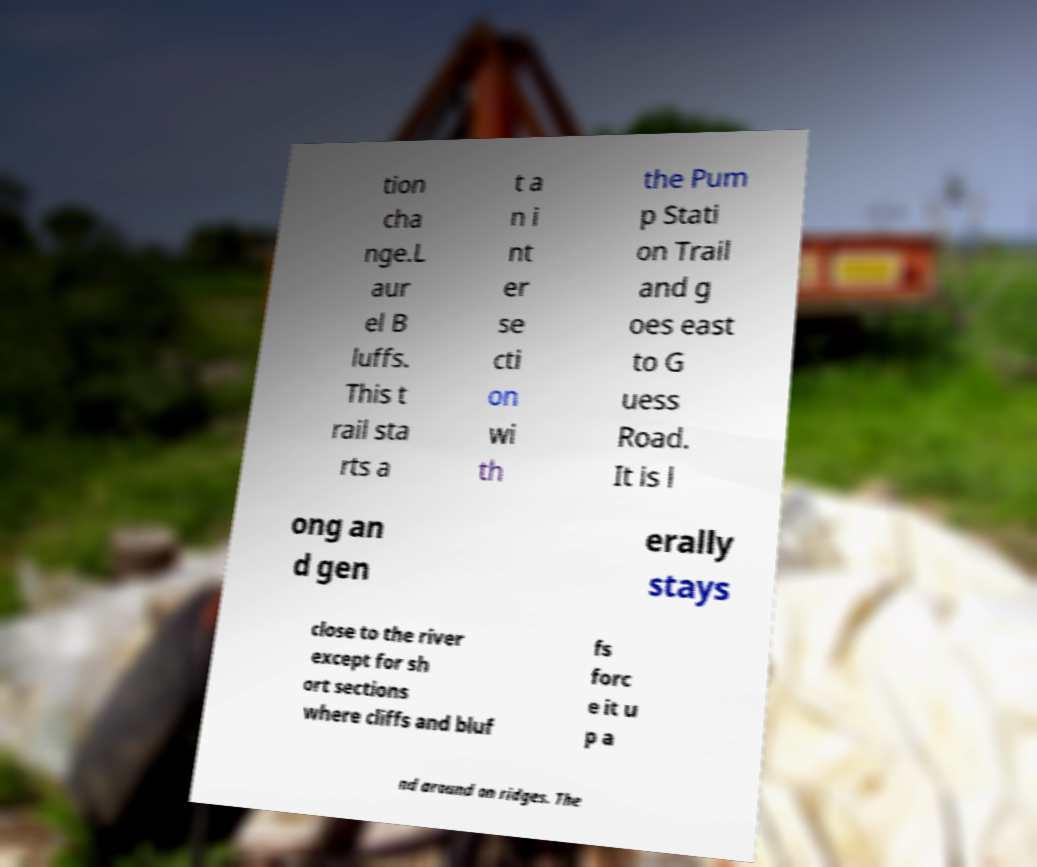Can you read and provide the text displayed in the image?This photo seems to have some interesting text. Can you extract and type it out for me? tion cha nge.L aur el B luffs. This t rail sta rts a t a n i nt er se cti on wi th the Pum p Stati on Trail and g oes east to G uess Road. It is l ong an d gen erally stays close to the river except for sh ort sections where cliffs and bluf fs forc e it u p a nd around on ridges. The 